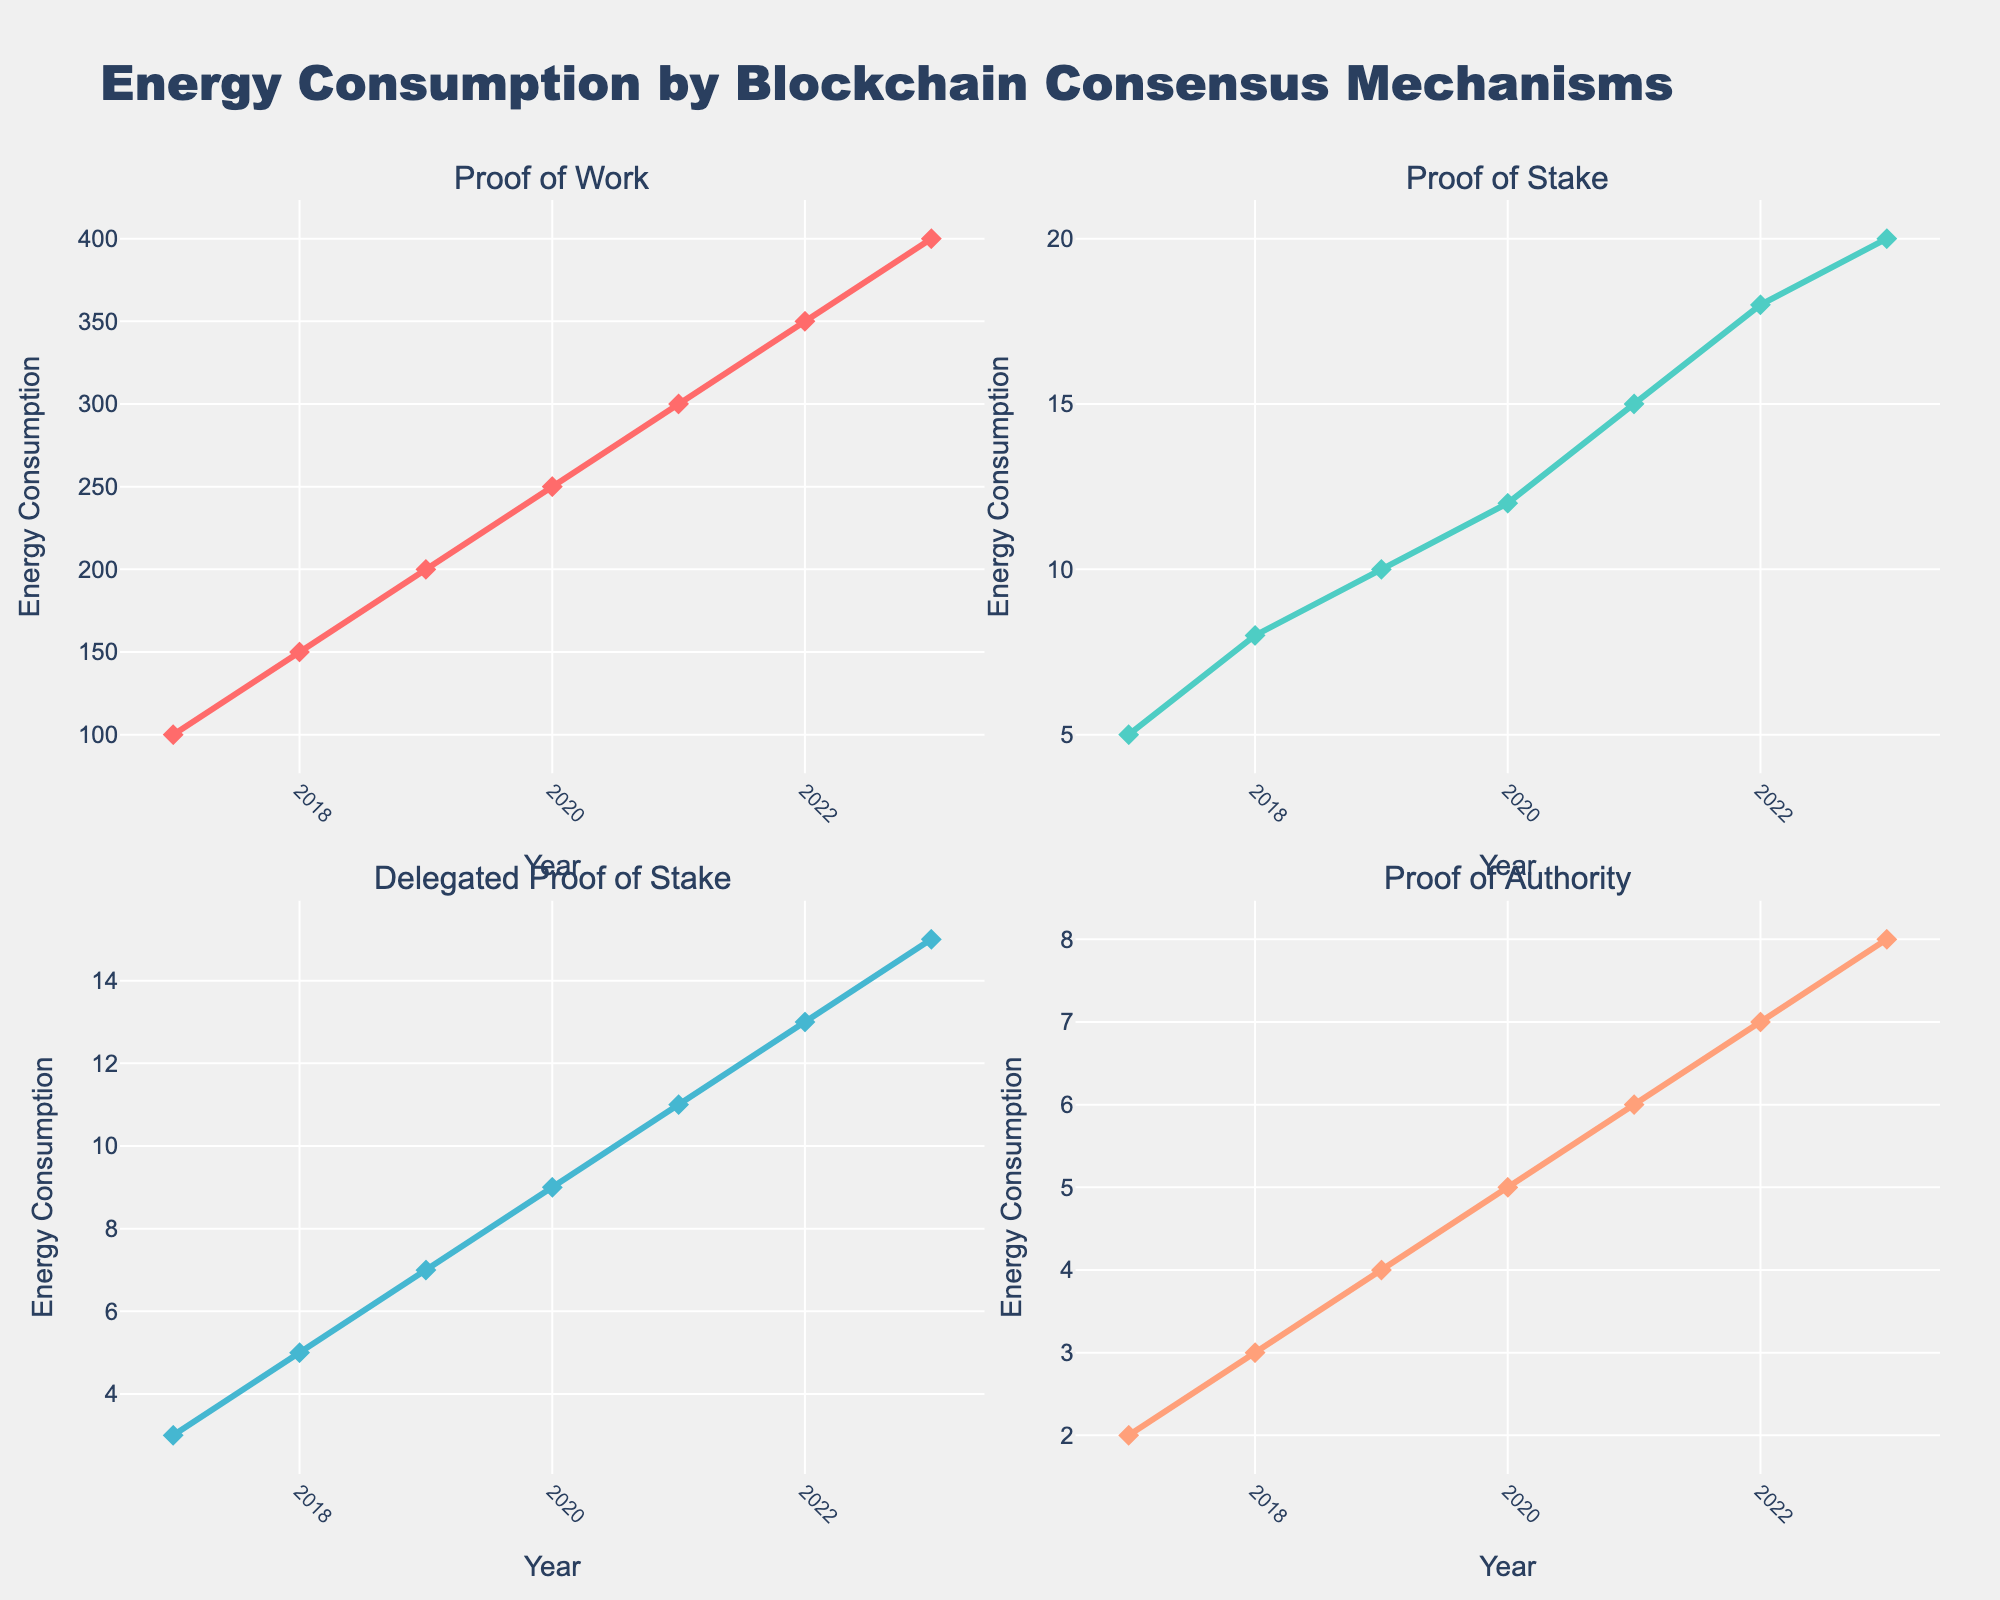What is the title of the chart? The title is located at the top of the figure and reads "Energy Consumption by Blockchain Consensus Mechanisms"
Answer: Energy Consumption by Blockchain Consensus Mechanisms How many subplots are in the figure? By visually inspecting, the figure is divided into sections, making up four quadrants with individual titles for each plot.
Answer: 4 What is the lowest energy consumption observed for Proof of Work? Locate the Proof of Work subplot, then identify the lowest point on the Y-axis. In 2017, the value is lowest at 100.
Answer: 100 Which blockchain consensus mechanism had the largest increase in energy consumption from 2017 to 2023? Compare the energy consumption values for 2017 and 2023 for all four mechanisms. Proof of Work increased from 100 to 400, which is an increase of 300, the highest among the mechanisms.
Answer: Proof of Work What is the energy consumption for Proof of Stake in 2020? Navigate to the Proof of Stake subplot and check the Y-axis value that aligns with the year 2020 on the X-axis, which is 12.
Answer: 12 Which two mechanisms had the closest energy consumption in 2021? For 2021, check the values for all mechanisms: Proof of Work (300), Proof of Stake (15), Delegated Proof of Stake (11), Proof of Authority (6). The closest are Delegated Proof of Stake and Proof of Authority with values 11 and 6, respectively.
Answer: Delegated Proof of Stake and Proof of Authority What is the average energy consumption of Delegated Proof of Stake from 2017 to 2023? Sum the energy consumption values for Delegated Proof of Stake from 2017 to 2023: 3 + 5 + 7 + 9 + 11 + 13 + 15 = 63. Divide by the number of years (7) to get the average: 63 / 7 = 9.
Answer: 9 Did Proof of Authority ever surpass Proof of Stake in energy consumption between 2017 and 2023? Compare the annual energy consumption values of Proof of Authority and Proof of Stake and check if Proof of Authority’s values are greater at any point. Proof of Stake always has higher values.
Answer: No In what year did Proof of Stake first reach an energy consumption of 10? Look at the Proof of Stake subplot to see the first year where the value is 10. It reached that value in 2019.
Answer: 2019 Arrange the blockchain mechanisms from highest to lowest energy consumption in 2023. Check the values for 2023: Proof of Work (400), Proof of Stake (20), Delegated Proof of Stake (15), Proof of Authority (8). Arrange them in descending order.
Answer: Proof of Work, Proof of Stake, Delegated Proof of Stake, Proof of Authority 